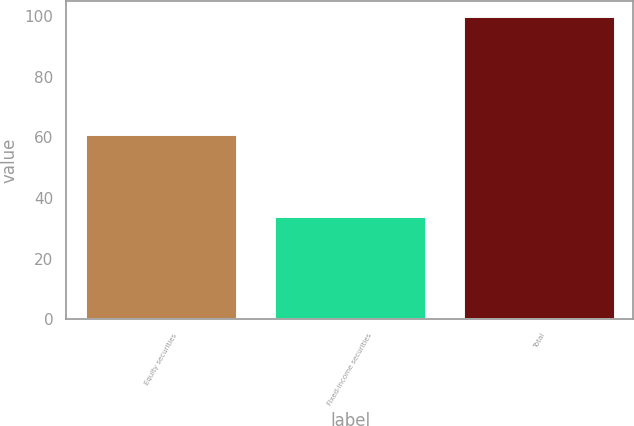Convert chart. <chart><loc_0><loc_0><loc_500><loc_500><bar_chart><fcel>Equity securities<fcel>Fixed-income securities<fcel>Total<nl><fcel>61<fcel>34<fcel>100<nl></chart> 